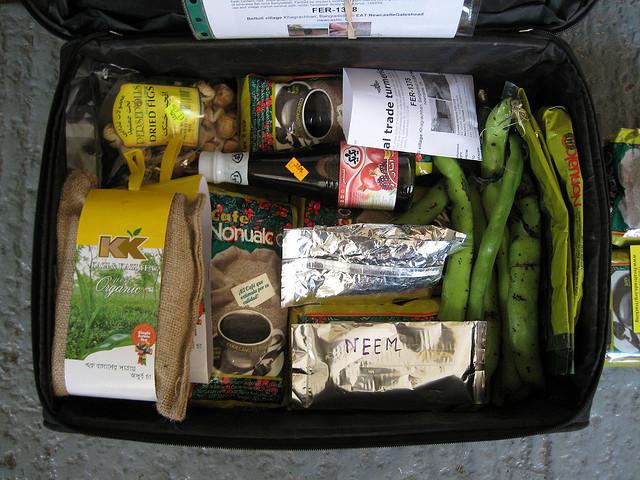Where are the dried figs?
Be succinct. Suitcase. What is the lunch kit color?
Write a very short answer. Black. Is there coffee in the bag?
Keep it brief. Yes. 